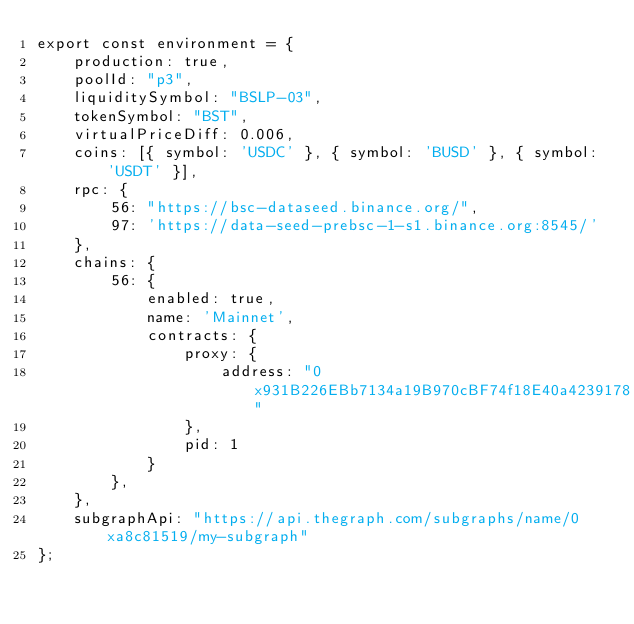<code> <loc_0><loc_0><loc_500><loc_500><_TypeScript_>export const environment = {
    production: true,
    poolId: "p3",
    liquiditySymbol: "BSLP-03",
    tokenSymbol: "BST",
    virtualPriceDiff: 0.006,
    coins: [{ symbol: 'USDC' }, { symbol: 'BUSD' }, { symbol: 'USDT' }],
    rpc: {
        56: "https://bsc-dataseed.binance.org/",
        97: 'https://data-seed-prebsc-1-s1.binance.org:8545/'
    },
    chains: {
        56: {
            enabled: true,
            name: 'Mainnet',
            contracts: {
                proxy: {
                    address: "0x931B226EBb7134a19B970cBF74f18E40a4239178"
                },
                pid: 1
            }
        },
    },
    subgraphApi: "https://api.thegraph.com/subgraphs/name/0xa8c81519/my-subgraph"
};
</code> 